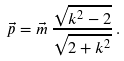<formula> <loc_0><loc_0><loc_500><loc_500>\vec { p } = \vec { m } \, { \frac { \sqrt { { k ^ { 2 } } - 2 } } { \sqrt { 2 + { k ^ { 2 } } } } } \, .</formula> 